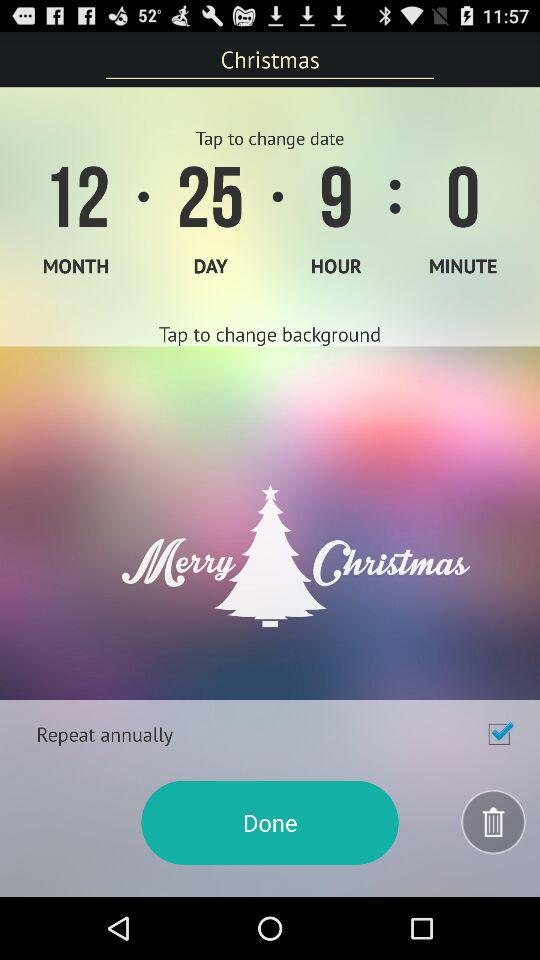What is the date? The date is December 25. 